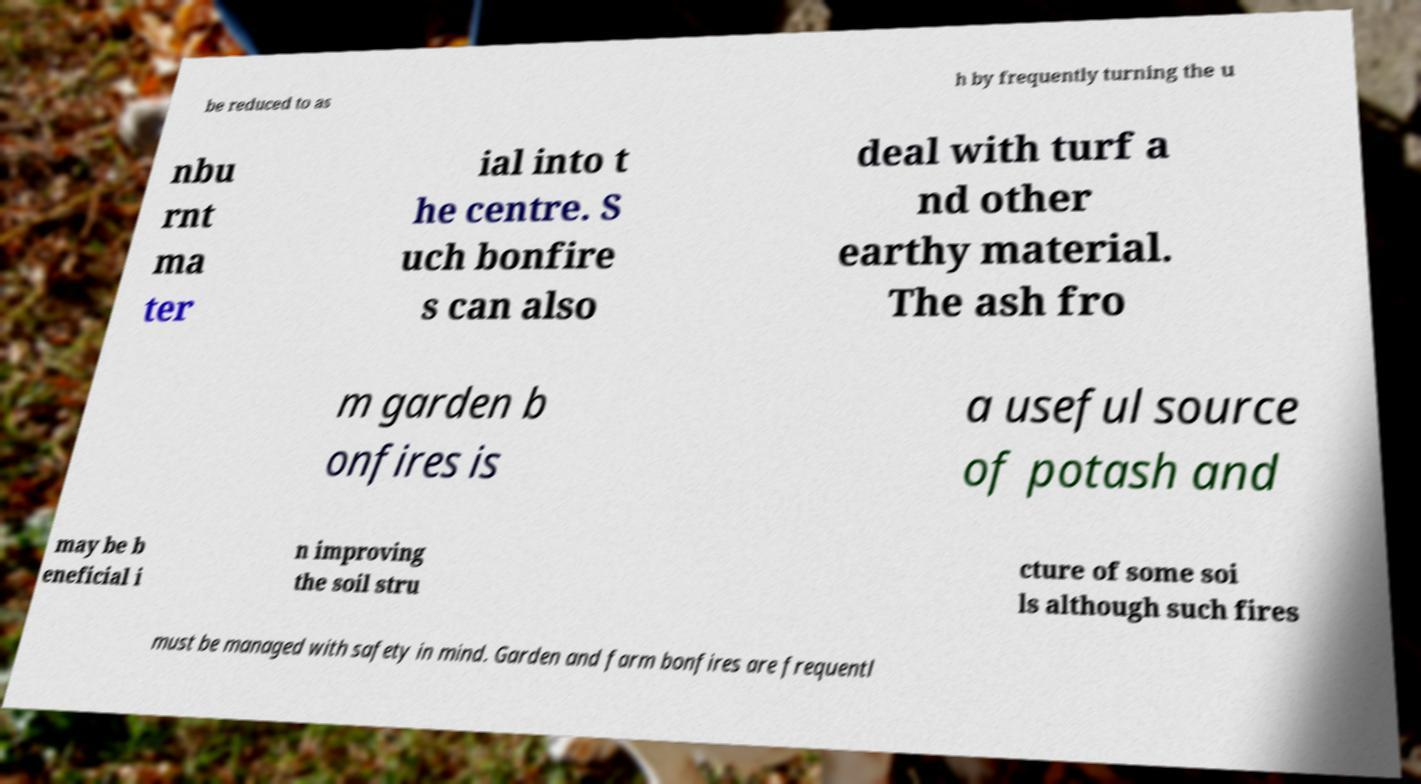Can you read and provide the text displayed in the image?This photo seems to have some interesting text. Can you extract and type it out for me? be reduced to as h by frequently turning the u nbu rnt ma ter ial into t he centre. S uch bonfire s can also deal with turf a nd other earthy material. The ash fro m garden b onfires is a useful source of potash and may be b eneficial i n improving the soil stru cture of some soi ls although such fires must be managed with safety in mind. Garden and farm bonfires are frequentl 